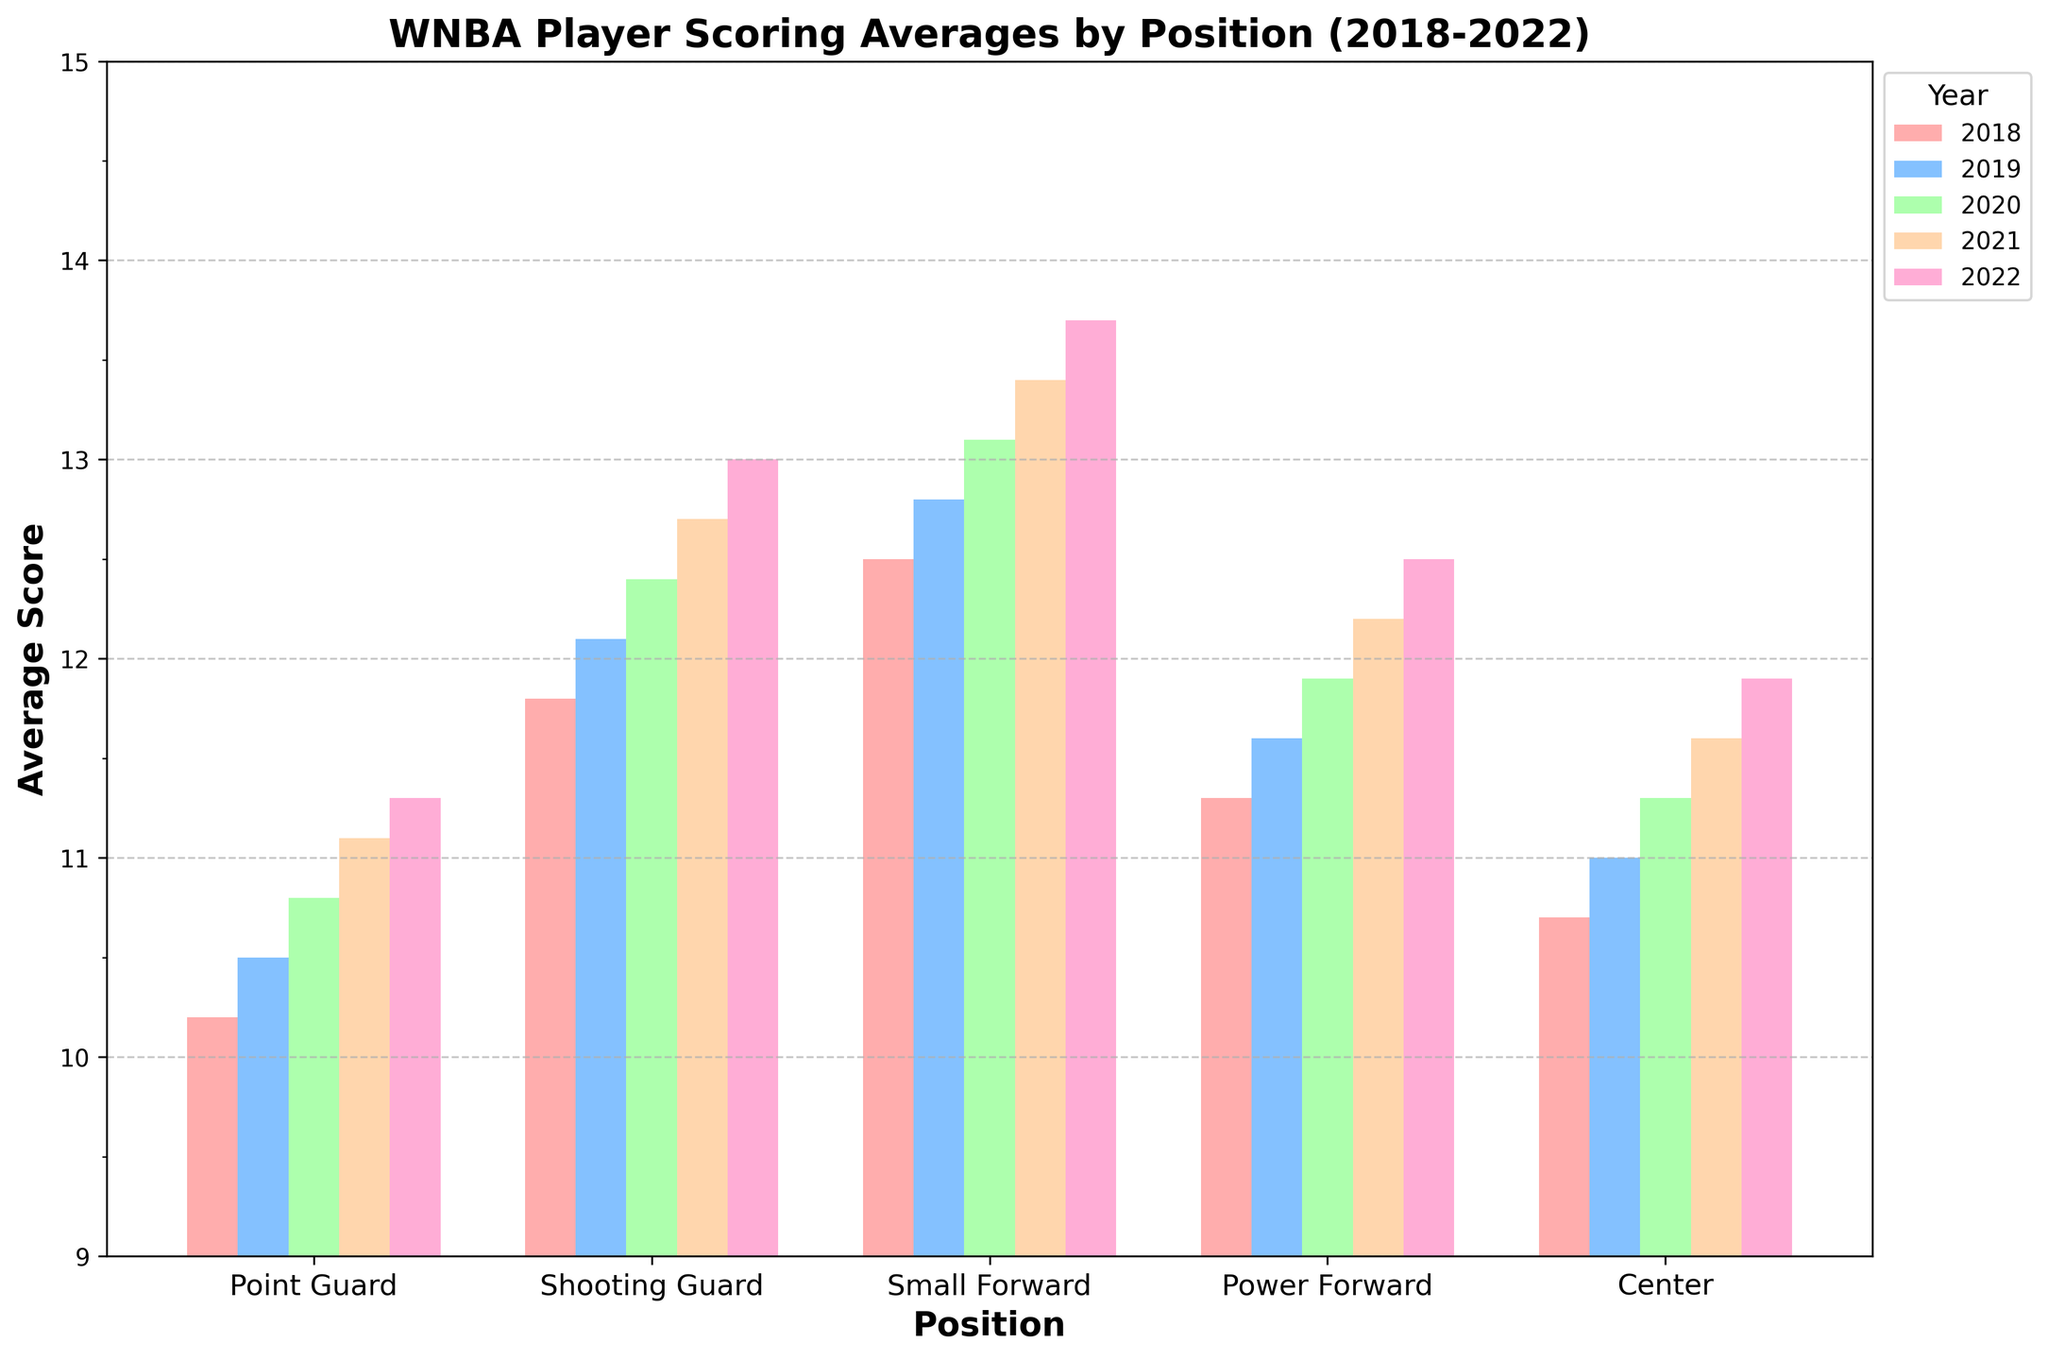What position had the highest scoring average in 2020? The tallest bar for the year 2020 corresponds to the Small Forward position.
Answer: Small Forward How does the average score of Centers in 2022 compare to that in 2018? Look at the bars for the Center position in both 2022 and 2018. Compare their heights or values, noting that the 2022 value is higher.
Answer: Higher Which position saw the greatest increase in scoring average from 2018 to 2022? Calculate the difference for each position between 2022 and 2018. The Small Forward position has the greatest increase (13.7 - 12.5 = 1.2).
Answer: Small Forward What is the difference in average scores between Point Guards and Shooting Guards in 2021? Subtract the average score of Point Guards (11.1) from Shooting Guards (12.7) for the year 2021.
Answer: 1.6 Which position had the smallest range in scoring averages between 2018 and 2022? Calculate the range (maximum - minimum) for each position from 2018 to 2022. The Center position has the smallest range (11.9 - 10.7 = 1.2).
Answer: Center What was the average scoring increase per year for Power Forwards from 2018 to 2022? Calculate the total increase (12.5 - 11.3 = 1.2) and divide by the number of years (4).
Answer: 0.3 Did any position have a consistent increase in scoring average every year from 2018 to 2022? Check each position's yearly values to see if they always increase. All positions show a consistent yearly increase in score.
Answer: Yes By how much did the average score for Shooting Guards increase from 2018 to 2019? Subtract the average score for 2018 (11.8) from 2019 (12.1).
Answer: 0.3 Which year had the smallest difference in average scoring between Point Guards and Small Forwards? Calculate the difference each year and compare: 2018 (12.5 - 10.2 = 2.3), 2019 (12.8 - 10.5 = 2.3), 2020 (13.1 - 10.8 = 2.3), 2021 (13.4 - 11.1 = 2.3), 2022 (13.7 - 11.3 = 2.4). The smallest differences are in 2018, 2019, and 2020.
Answer: 2018, 2019, 2020 What is the total combined average score of all positions in 2022? Add the averages for each position in 2022 (11.3 + 13.0 + 13.7 + 12.5 + 11.9).
Answer: 62.4 